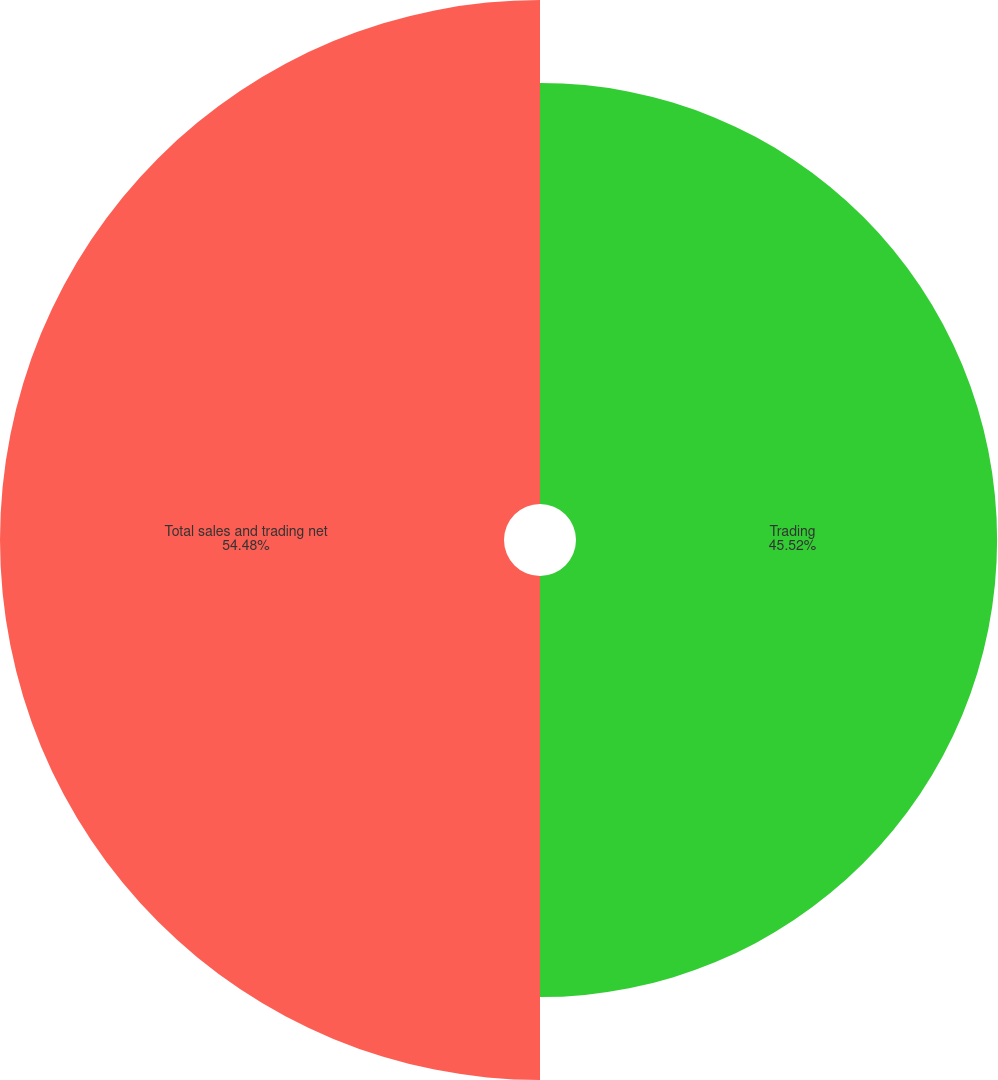<chart> <loc_0><loc_0><loc_500><loc_500><pie_chart><fcel>Trading<fcel>Total sales and trading net<nl><fcel>45.52%<fcel>54.48%<nl></chart> 